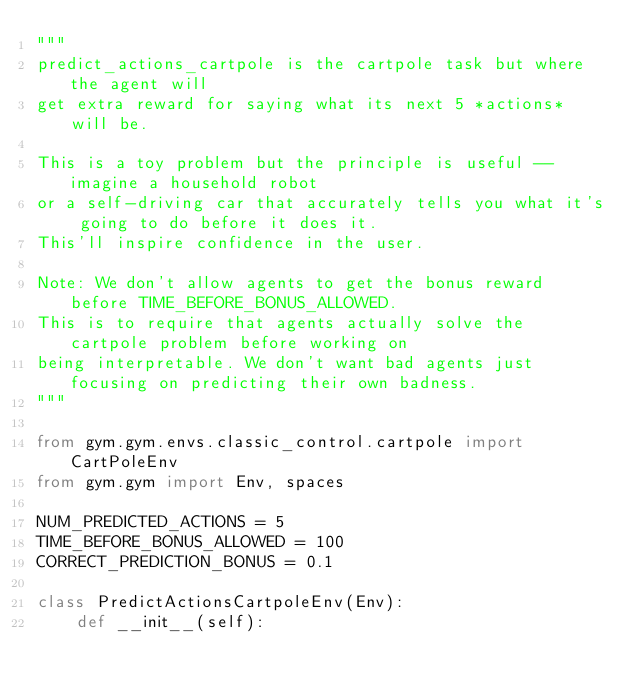<code> <loc_0><loc_0><loc_500><loc_500><_Python_>"""
predict_actions_cartpole is the cartpole task but where the agent will
get extra reward for saying what its next 5 *actions* will be.

This is a toy problem but the principle is useful -- imagine a household robot
or a self-driving car that accurately tells you what it's going to do before it does it.
This'll inspire confidence in the user.

Note: We don't allow agents to get the bonus reward before TIME_BEFORE_BONUS_ALLOWED.
This is to require that agents actually solve the cartpole problem before working on
being interpretable. We don't want bad agents just focusing on predicting their own badness.
"""

from gym.gym.envs.classic_control.cartpole import CartPoleEnv
from gym.gym import Env, spaces

NUM_PREDICTED_ACTIONS = 5
TIME_BEFORE_BONUS_ALLOWED = 100
CORRECT_PREDICTION_BONUS = 0.1

class PredictActionsCartpoleEnv(Env):
    def __init__(self):</code> 